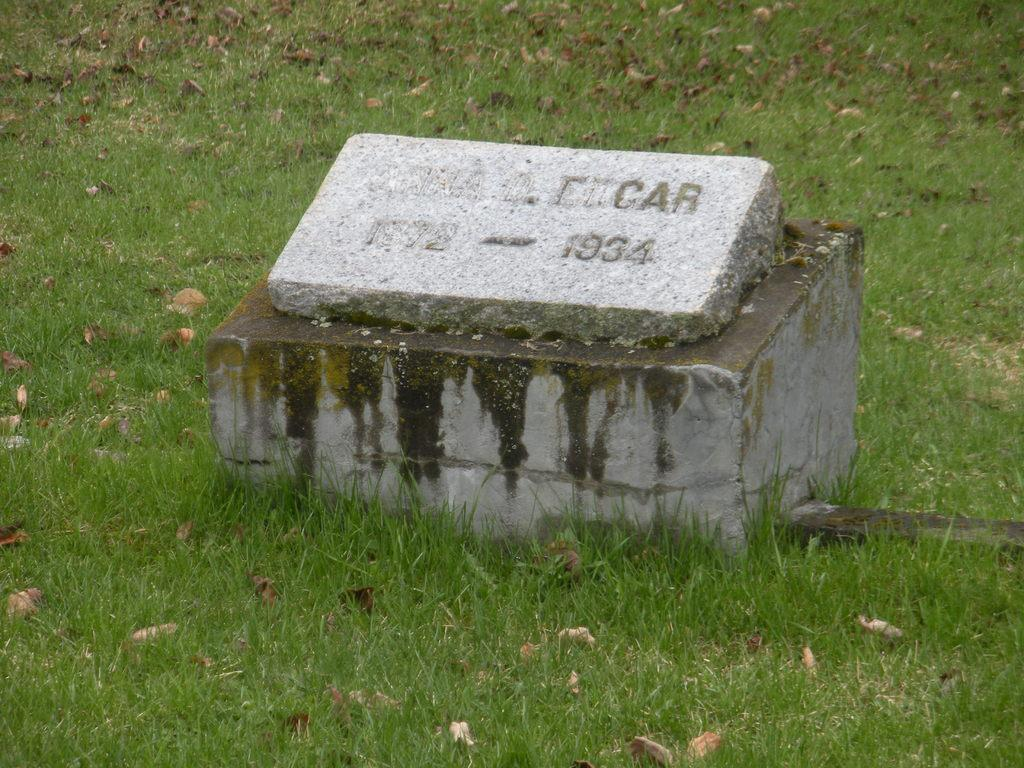What type of vegetation is present on the ground in the image? There is grass on the ground in the image. What else can be seen on the ground besides the grass? There are dry leaves on the ground in the image. What structure is located in the middle of the ground? There is a small pillar with a cement plate in the middle of the ground. What is written on the cement plate? There is something written on the cement plate. Can you see any icicles hanging from the small pillar in the image? There are no icicles present in the image. What type of cake is placed on the cement plate in the image? There is no cake present in the image; it features a small pillar with a cement plate and something written on it. 